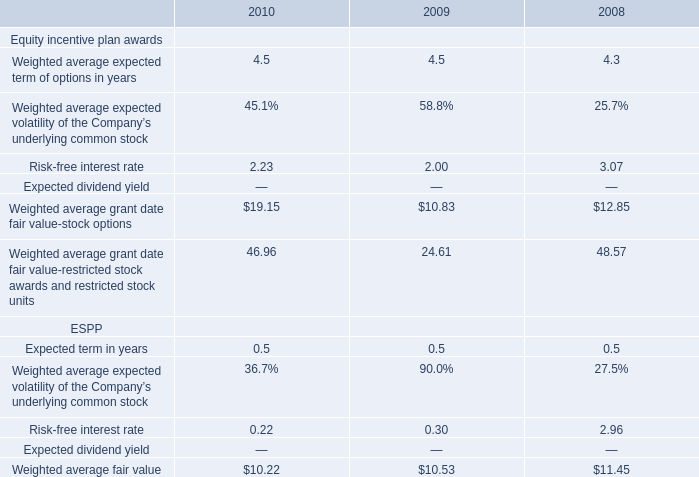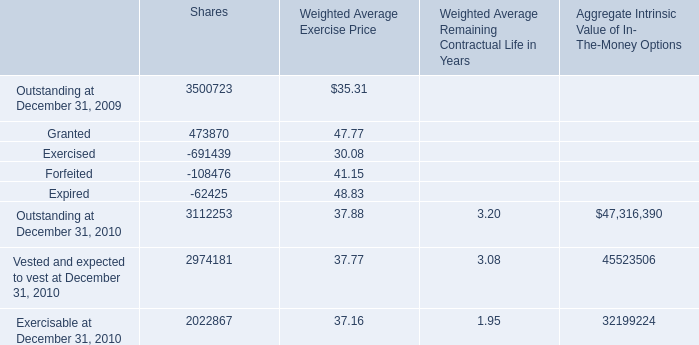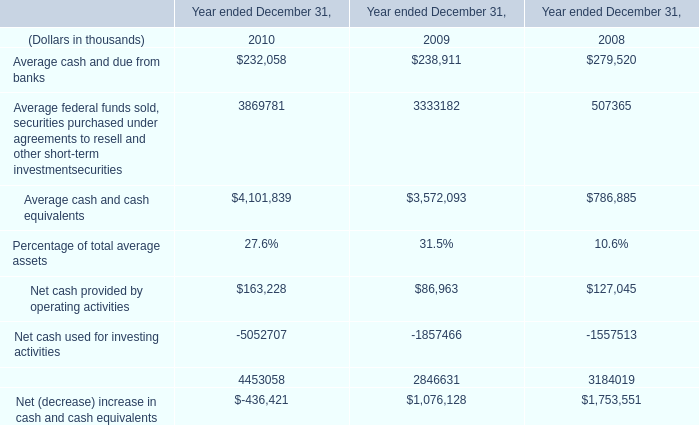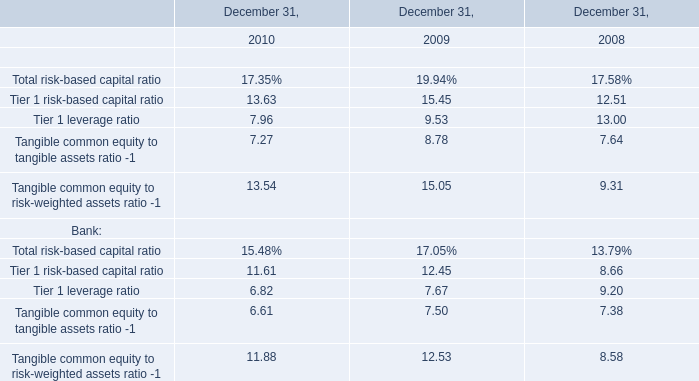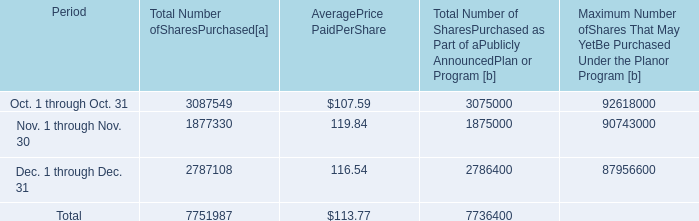what percent of the share repurchases were in the fourth quarter? 
Computations: (7751987 / 33035204)
Answer: 0.23466. 